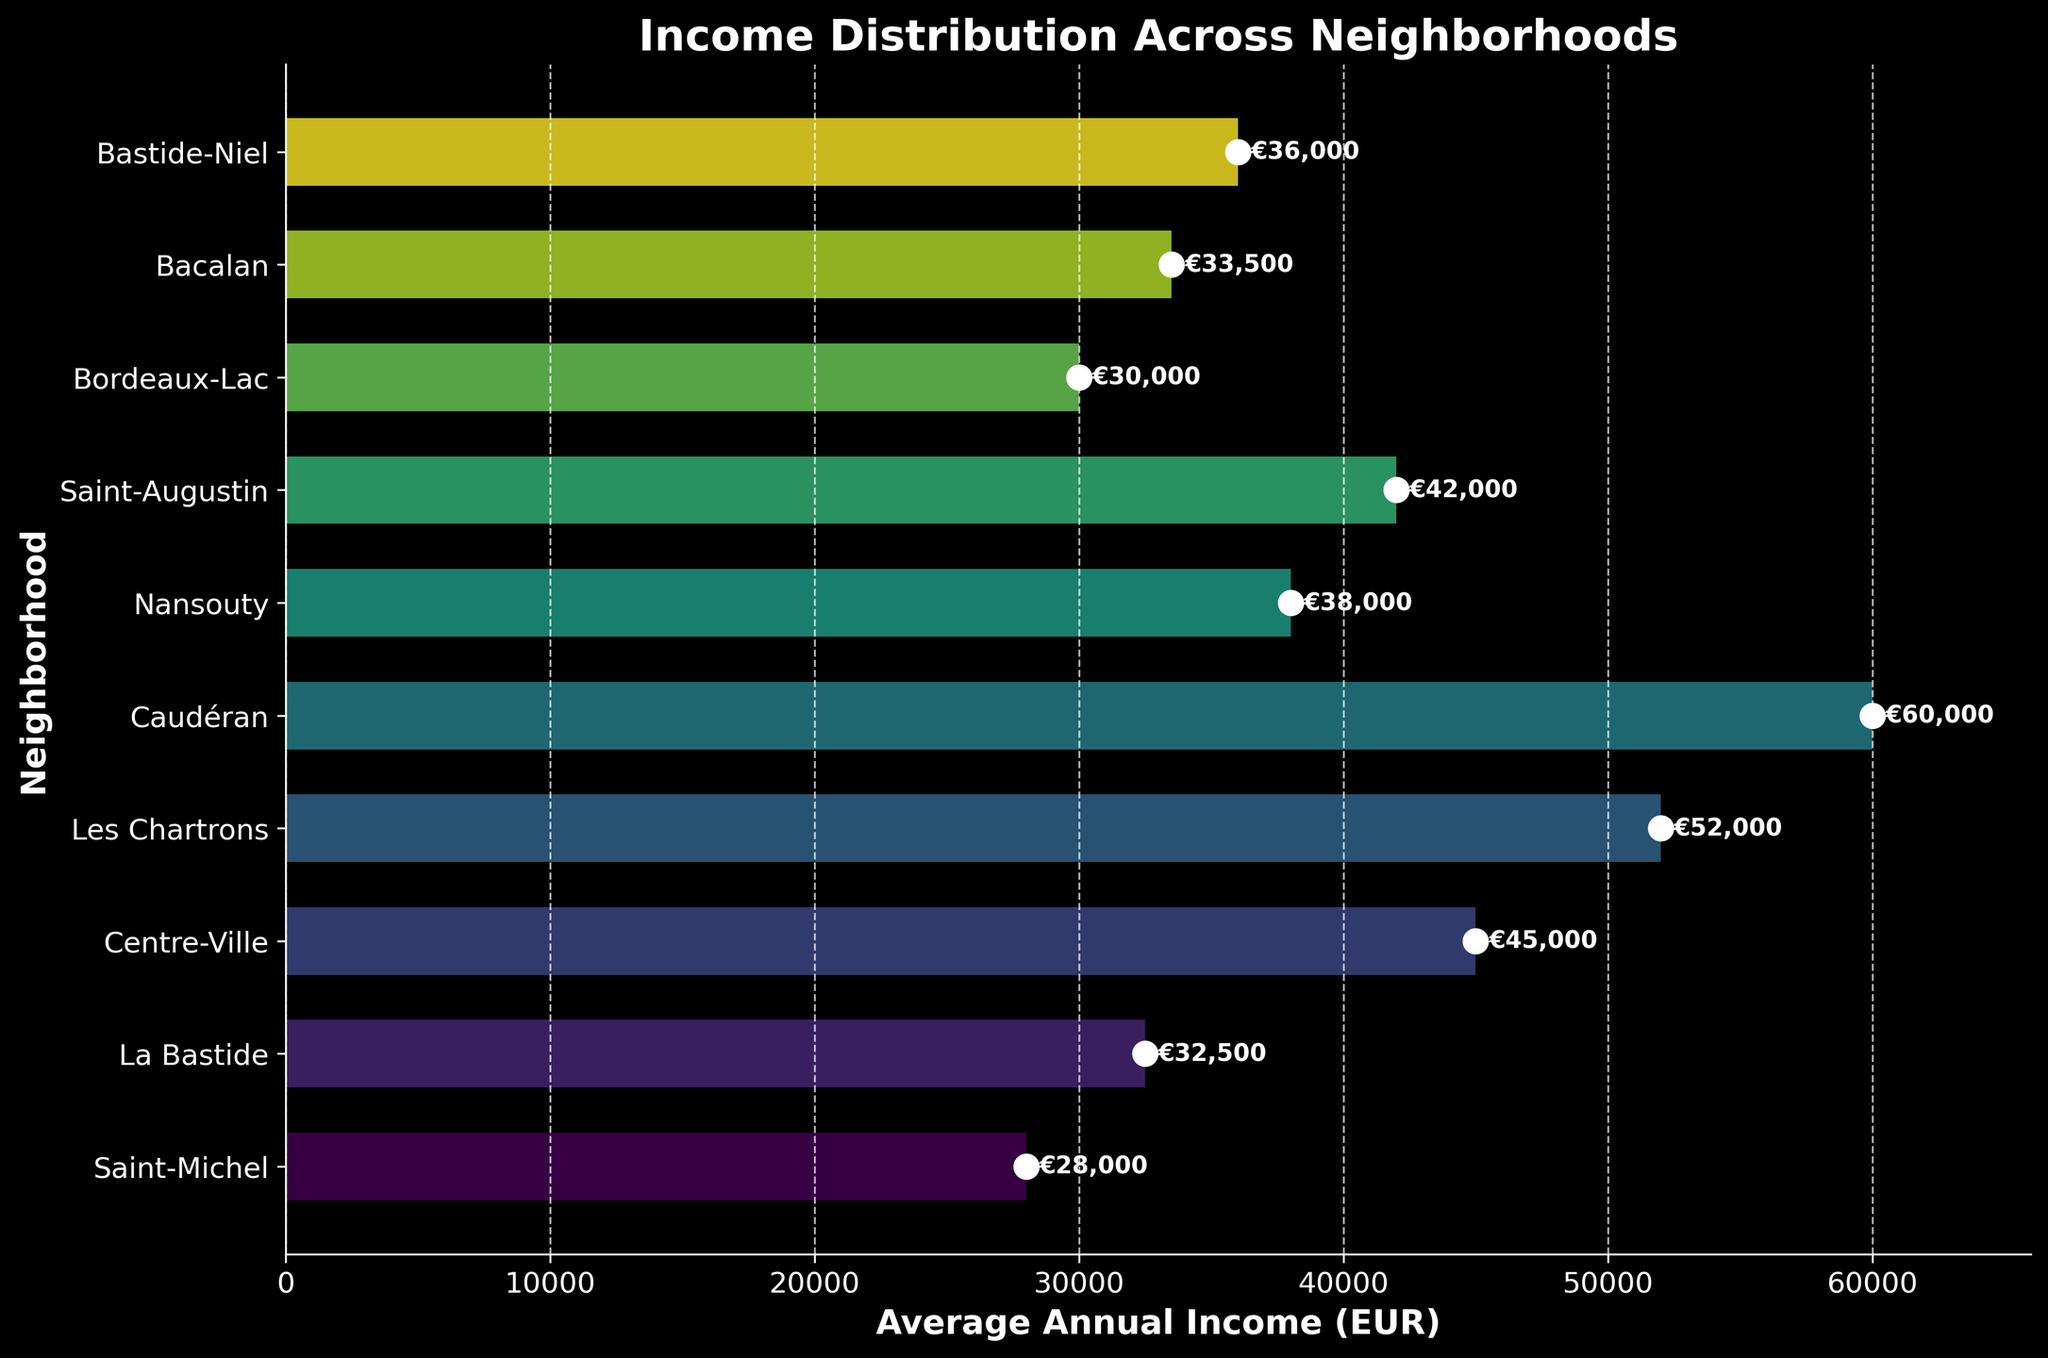What is the title of the plot? The title is found at the top of the plot in large, bold font.
Answer: Income Distribution Across Neighborhoods What is the average annual income in the Caudéran neighborhood? The value is displayed on the horizontal bar corresponding to "Caudéran". It is also visible as a text label beside the bar.
Answer: €60,000 Which neighborhood has the lowest average annual income? By examining the bar heights, the shortest bar represents the neighborhood with the lowest income.
Answer: Saint-Michel What is the difference in average annual income between Les Chartrons and Bacalan? Identify the incomes for both neighborhoods from the plot and subtract the lower income from the higher one. Les Chartrons: €52,000, Bacalan: €33,500. So, the difference is €52,000 - €33,500.
Answer: €18,500 How many neighborhoods have an average annual income greater than €40,000? Count the number of horizontal bars that exceed the €40,000 mark on the x-axis.
Answer: 3 What is the income range (difference between the highest and lowest incomes) depicted in the plot? Identify the highest and lowest incomes from the bars. Subtract the lowest income from the highest. Highest income: €60,000 (Caudéran), Lowest income: €28,000 (Saint-Michel). So, the range is €60,000 - €28,000.
Answer: €32,000 Which neighborhood has an average annual income closest to the median income of all neighborhoods? Arrange the incomes in ascending order and find the middle value. The neighborhoods' incomes in order are: €28,000, €30,000, €32,500, €33,500, €36,000, €38,000, €42,000, €45,000, €52,000, €60,000. The median is between €33,500 and €36,000, so the Centerville-Niel neighborhood's income of €36,000 is closest.
Answer: Bastide-Niel How does the income in Saint-Michel compare to the income in Bordeaux-Lac? Compare the lengths of the bars for both neighborhoods. Saint-Michel has the lowest income (€28,000), while Bordeaux-Lac has a higher income (€30,000).
Answer: Bordeaux-Lac has higher income Is there a neighborhood with an average annual income of €40,000 or more but less than €50,000? Check the bar lengths and corresponding text labels for any neighborhood falling within this income range. Saint-Augustin has an income of €42,000 and Centre-Ville has an income of €45,000.
Answer: Yes 